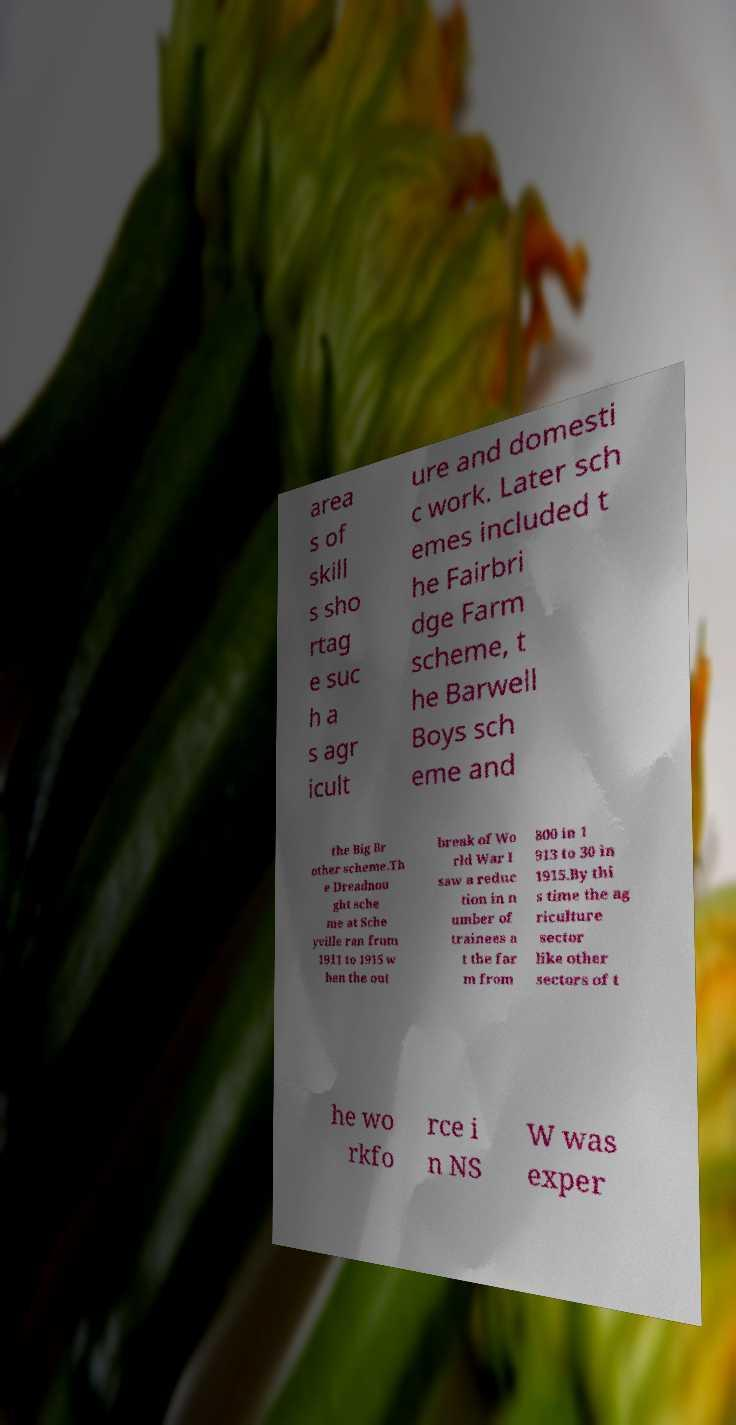Please identify and transcribe the text found in this image. area s of skill s sho rtag e suc h a s agr icult ure and domesti c work. Later sch emes included t he Fairbri dge Farm scheme, t he Barwell Boys sch eme and the Big Br other scheme.Th e Dreadnou ght sche me at Sche yville ran from 1911 to 1915 w hen the out break of Wo rld War I saw a reduc tion in n umber of trainees a t the far m from 800 in 1 913 to 30 in 1915.By thi s time the ag riculture sector like other sectors of t he wo rkfo rce i n NS W was exper 